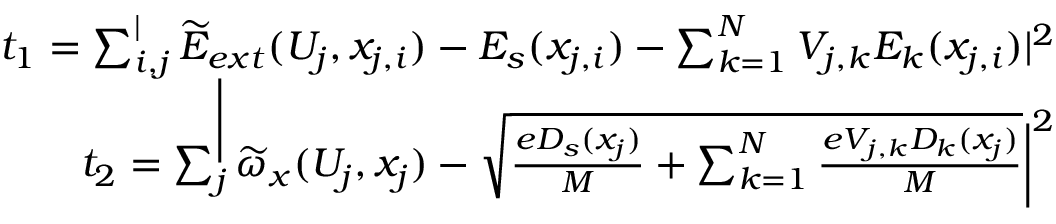<formula> <loc_0><loc_0><loc_500><loc_500>\begin{array} { r } { t _ { 1 } = \sum _ { i , j } ^ { | } \widetilde { E } _ { e x t } ( U _ { j } , x _ { j , i } ) - E _ { s } ( x _ { j , i } ) - \sum _ { k = 1 } ^ { N } V _ { j , k } E _ { k } ( x _ { j , i } ) | ^ { 2 } } \\ { t _ { 2 } = \sum _ { j } ^ { \Big } | \widetilde { \omega } _ { x } ( U _ { j } , x _ { j } ) - \sqrt { \frac { e D _ { s } ( x _ { j } ) } { M } + \sum _ { k = 1 } ^ { N } \frac { e V _ { j , k } D _ { k } ( x _ { j } ) } { M } } \Big | ^ { 2 } } \end{array}</formula> 